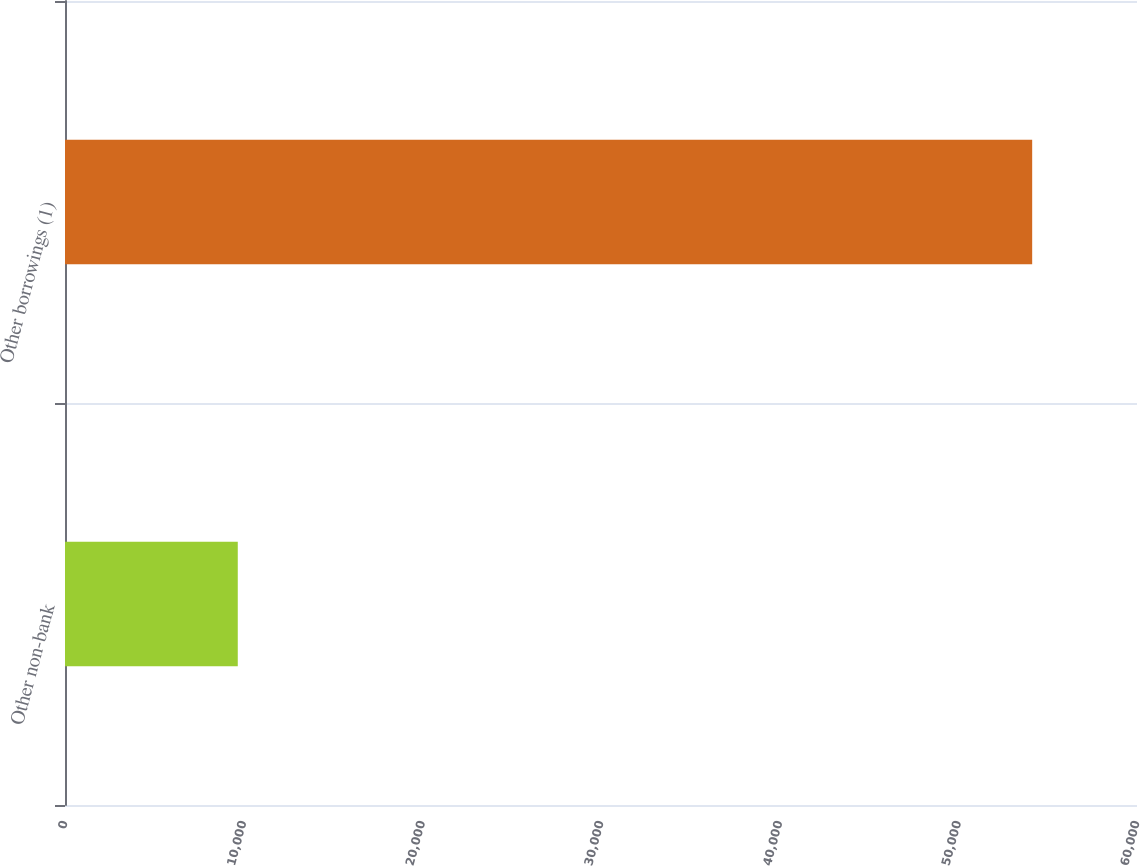Convert chart to OTSL. <chart><loc_0><loc_0><loc_500><loc_500><bar_chart><fcel>Other non-bank<fcel>Other borrowings (1)<nl><fcel>9670<fcel>54133<nl></chart> 